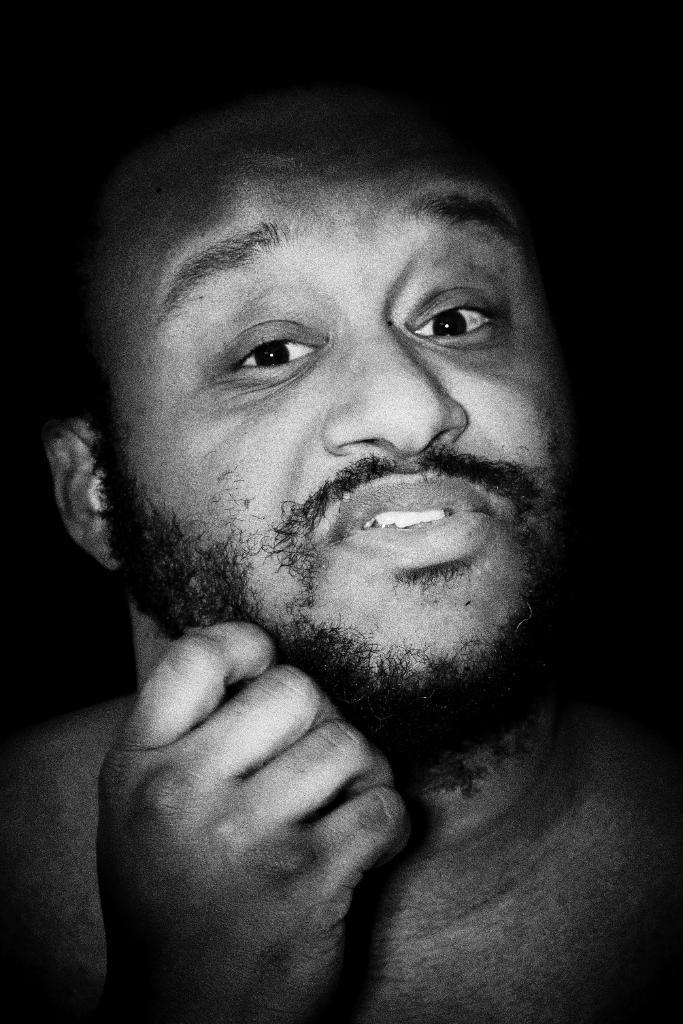Who is present in the image? There is a man in the image. What is the man doing or where is he located in the image? The man is present over a place. What can be determined about the man's emotions or feelings from the image? The facial expression of the man is visible in the image. What type of boat can be seen in the image? There is no boat present in the image; it features a man over a place. What thrilling activity is the man participating in the image? The image does not depict any specific activity or thrill; it only shows a man with a visible facial expression. 